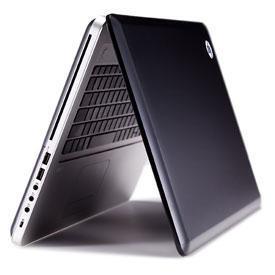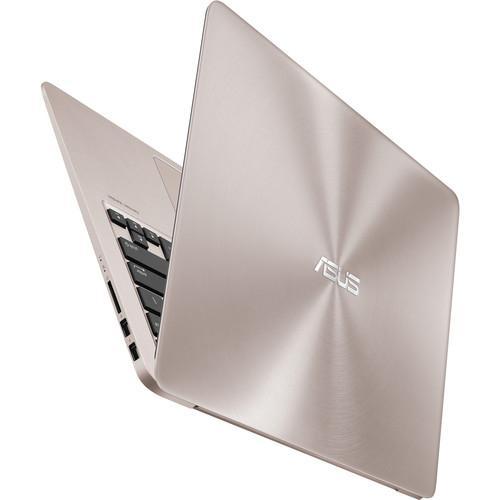The first image is the image on the left, the second image is the image on the right. Evaluate the accuracy of this statement regarding the images: "You cannot see the screen of the laptop on the right side of the image.". Is it true? Answer yes or no. Yes. 